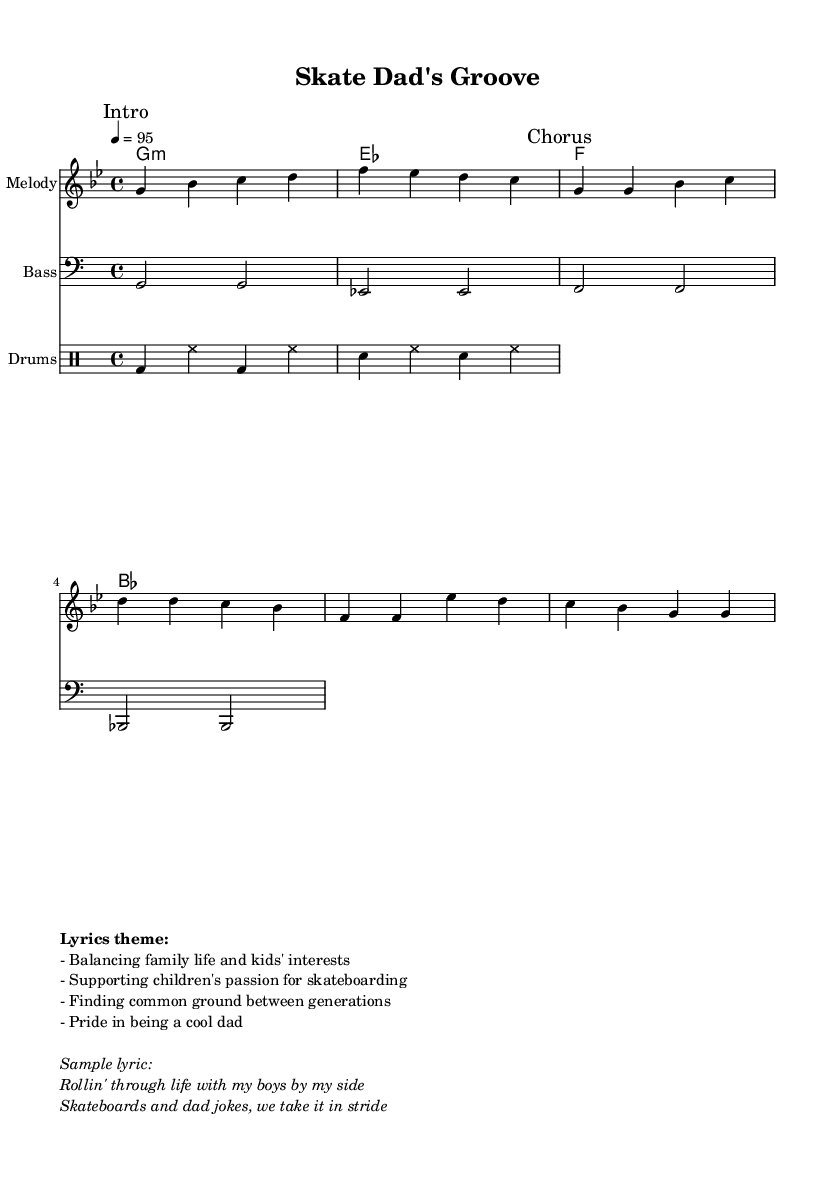What is the key signature of this music? The key signature indicated in the sheet music is G minor, which has two flats (B flat and E flat).
Answer: G minor What is the time signature of this music? The time signature shown in the music is 4/4, which means there are four beats in a measure and the quarter note gets one beat.
Answer: 4/4 What is the tempo marking for this piece? The tempo marking is set at a quarter note equals 95 beats per minute, which indicates a moderately fast tempo.
Answer: 95 What is the main theme of the lyrics in this piece? The lyrics revolve around balancing family life with supporting children's interests, particularly in skateboarding, highlighting family bonds and pride in fatherhood.
Answer: Balancing family life and kids' interests How many measures are there in the chorus section? By looking at the melody section, the chorus consists of four measures, containing various repeated notes and phrases related to the upbeat theme.
Answer: Four measures What is a sample lyric from this music? A lyric highlighted in the markup section is "Rollin' through life with my boys by my side," which emphasizes the family relationship and activities shared between father and sons.
Answer: Rollin' through life with my boys by my side 